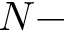Convert formula to latex. <formula><loc_0><loc_0><loc_500><loc_500>N -</formula> 